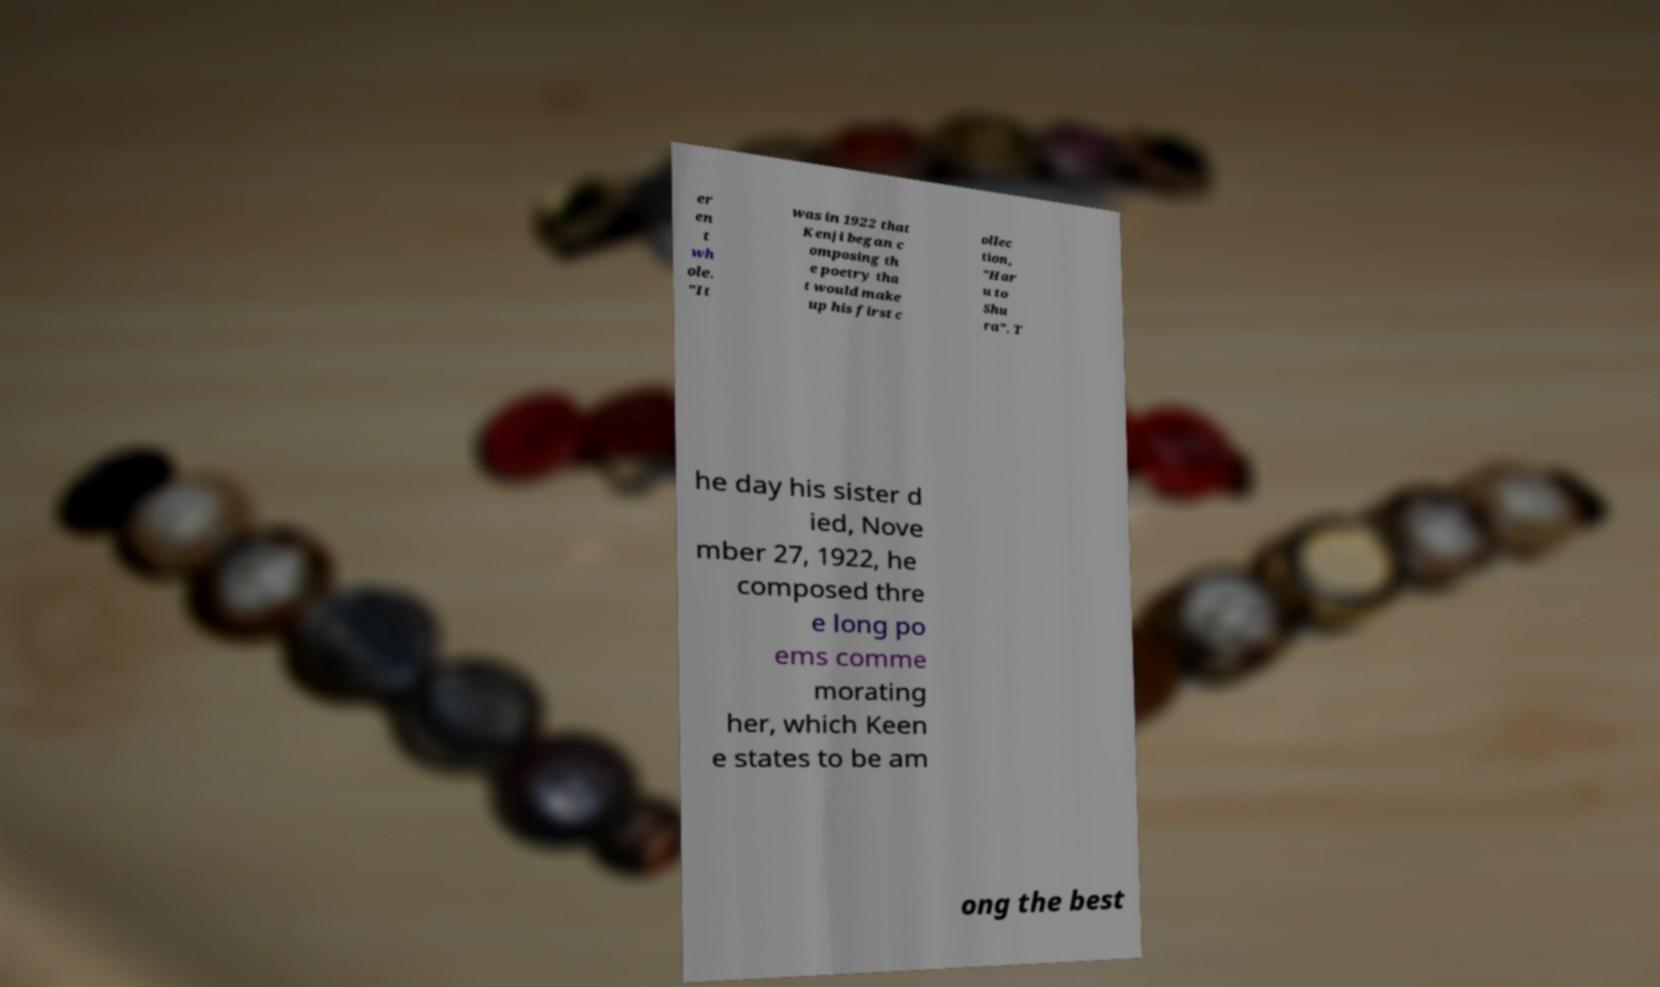There's text embedded in this image that I need extracted. Can you transcribe it verbatim? er en t wh ole. "It was in 1922 that Kenji began c omposing th e poetry tha t would make up his first c ollec tion, "Har u to Shu ra". T he day his sister d ied, Nove mber 27, 1922, he composed thre e long po ems comme morating her, which Keen e states to be am ong the best 